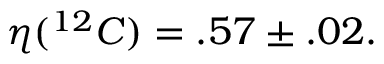<formula> <loc_0><loc_0><loc_500><loc_500>\eta ( ^ { 1 2 } C ) = . 5 7 \pm . 0 2 .</formula> 